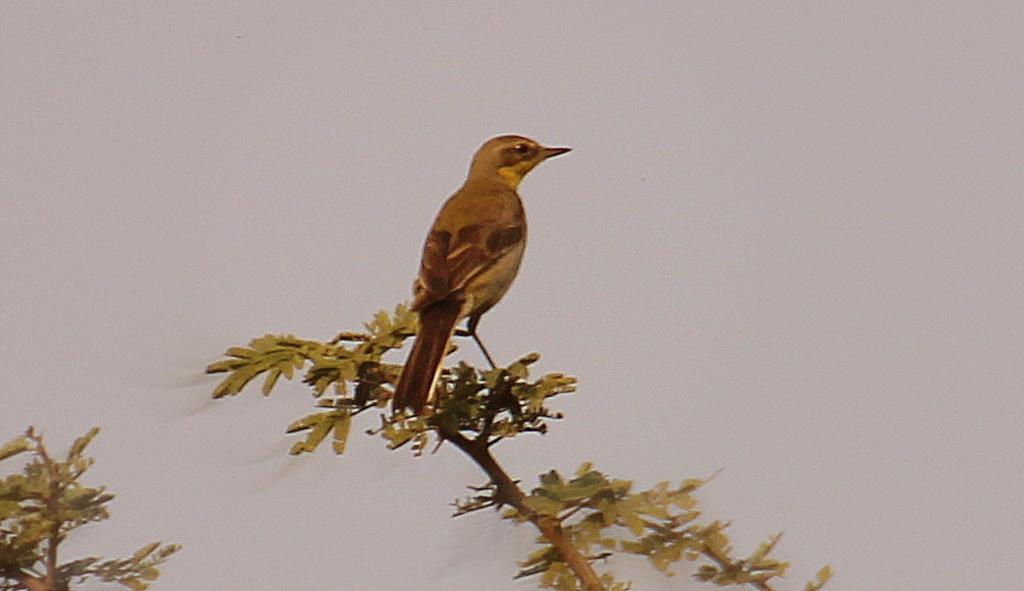What type of plant elements are present in the image? There are leaves on stems in the image. What animal can be seen in the image? There is a bird in the center of the image. What color is the background of the image? The background of the image is white. What shape is the zephyr in the image? There is no zephyr present in the image, as a zephyr refers to a gentle breeze and cannot be seen or have a shape. 